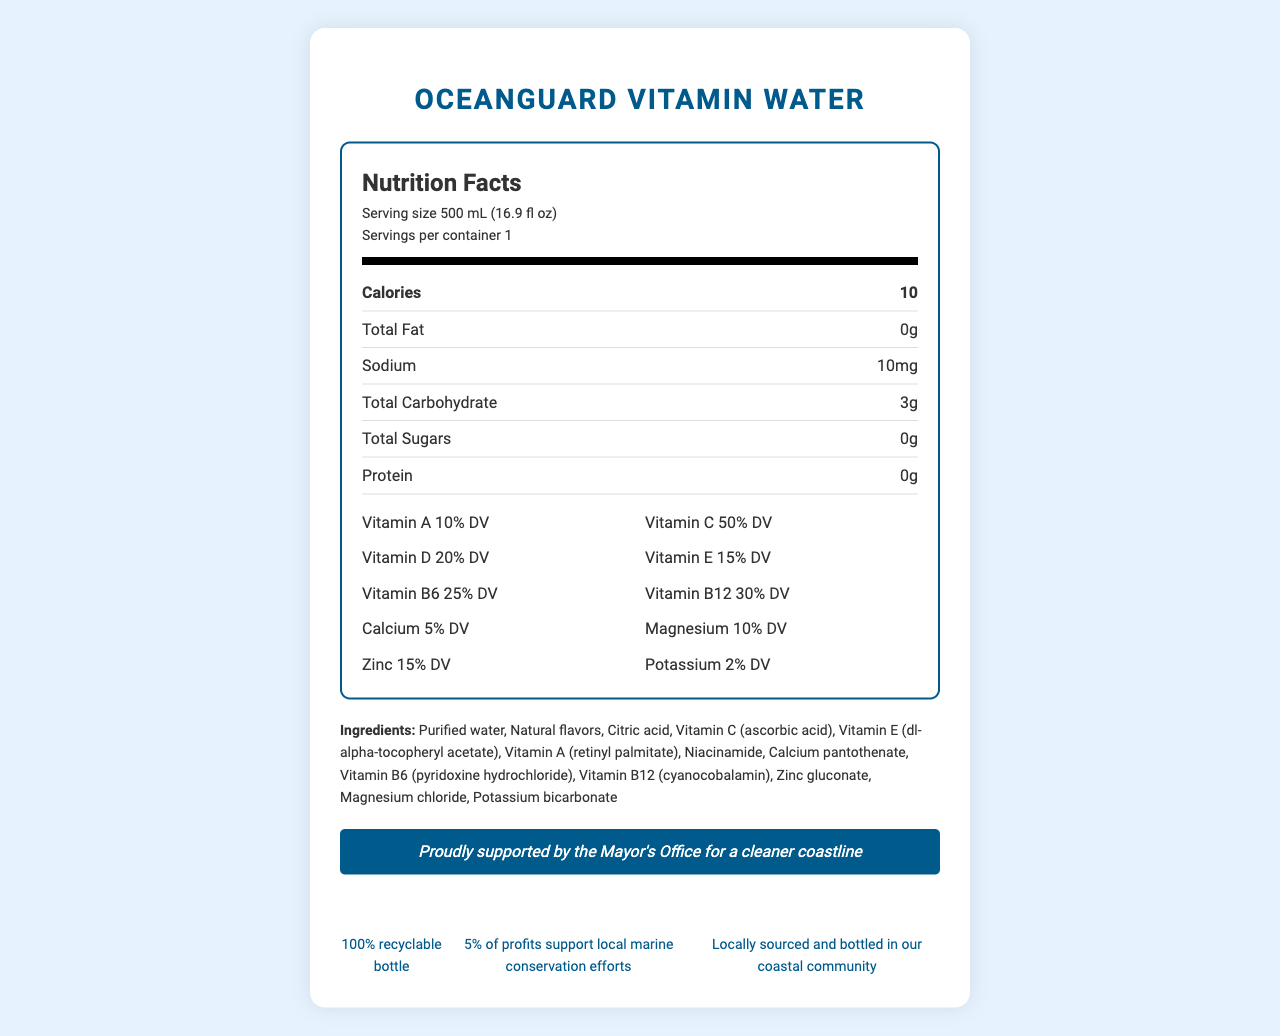what is the serving size of OceanGuard Vitamin Water? The serving size is clearly listed under the Nutrition Facts section of the document.
Answer: 500 mL (16.9 fl oz) how many calories are in one serving of OceanGuard Vitamin Water? The number of calories per serving is stated directly in the Nutrition Facts section.
Answer: 10 What percentage of Vitamin C does one serving provide? The Nutrition Facts specify that one serving provides 50% of the daily value of Vitamin C.
Answer: 50% DV What ingredients are used in OceanGuard Vitamin Water? The ingredients are listed in the ingredients section of the document.
Answer: Purified water, Natural flavors, Citric acid, Vitamin C (ascorbic acid), Vitamin E (dl-alpha-tocopheryl acetate), Vitamin A (retinyl palmitate), Niacinamide, Calcium pantothenate, Vitamin B6 (pyridoxine hydrochloride), Vitamin B12 (cyanocobalamin), Zinc gluconate, Magnesium chloride, Potassium bicarbonate How much sodium is in a serving of OceanGuard Vitamin Water? The amount of sodium per serving is mentioned in the Nutrition Facts.
Answer: 10 mg Which vitamin has the highest percentage daily value in OceanGuard Vitamin Water? The document states that Vitamin C has a daily value percentage of 50%, which is the highest among the listed vitamins.
Answer: Vitamin C How should OceanGuard Vitamin Water be stored? A. In a warm place B. At room temperature C. In a cool, dry place The storage instructions specify to store it in a cool, dry place.
Answer: C Is the OceanGuard Vitamin Water bottle recyclable? A. Yes B. No C. Only partially The document mentions that the bottle is 100% recyclable.
Answer: A Does the document provide information about potential allergens in OceanGuard Vitamin Water? A. Yes B. No The allergen information section states that it is produced in a facility that processes soy and tree nuts.
Answer: A Does OceanGuard Vitamin Water support any conservation efforts? 5% of profits support local marine conservation efforts, as stated in the conservation statement.
Answer: Yes Who endorsed OceanGuard Vitamin Water? The endorsement section clearly states that it is proudly supported by the Mayor's Office for a cleaner coastline.
Answer: The Mayor's Office How would you describe the main purpose of the document? The document serves to inform consumers about the nutritional contents and benefits of the product, along with the mayoral endorsement and its support for marine conservation.
Answer: The document provides detailed nutritional information, ingredients, and additional details about OceanGuard Vitamin Water, including endorsements, conservation efforts, and storage instructions. What is the shelf life of OceanGuard Vitamin Water? The document only says "Best if used by date on bottle," but it doesn't provide the actual shelf life duration.
Answer: Not enough information What percentage of profits from OceanGuard Vitamin Water supports marine conservation efforts? The conservation statement in the document specifies that 5% of profits support local marine conservation efforts.
Answer: 5% 